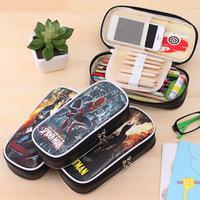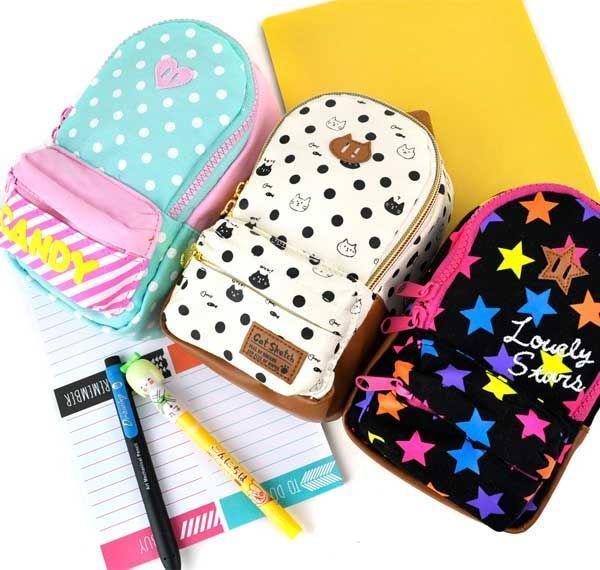The first image is the image on the left, the second image is the image on the right. Considering the images on both sides, is "The left image includes a pair of eyeglasses at least partly visible." valid? Answer yes or no. Yes. 